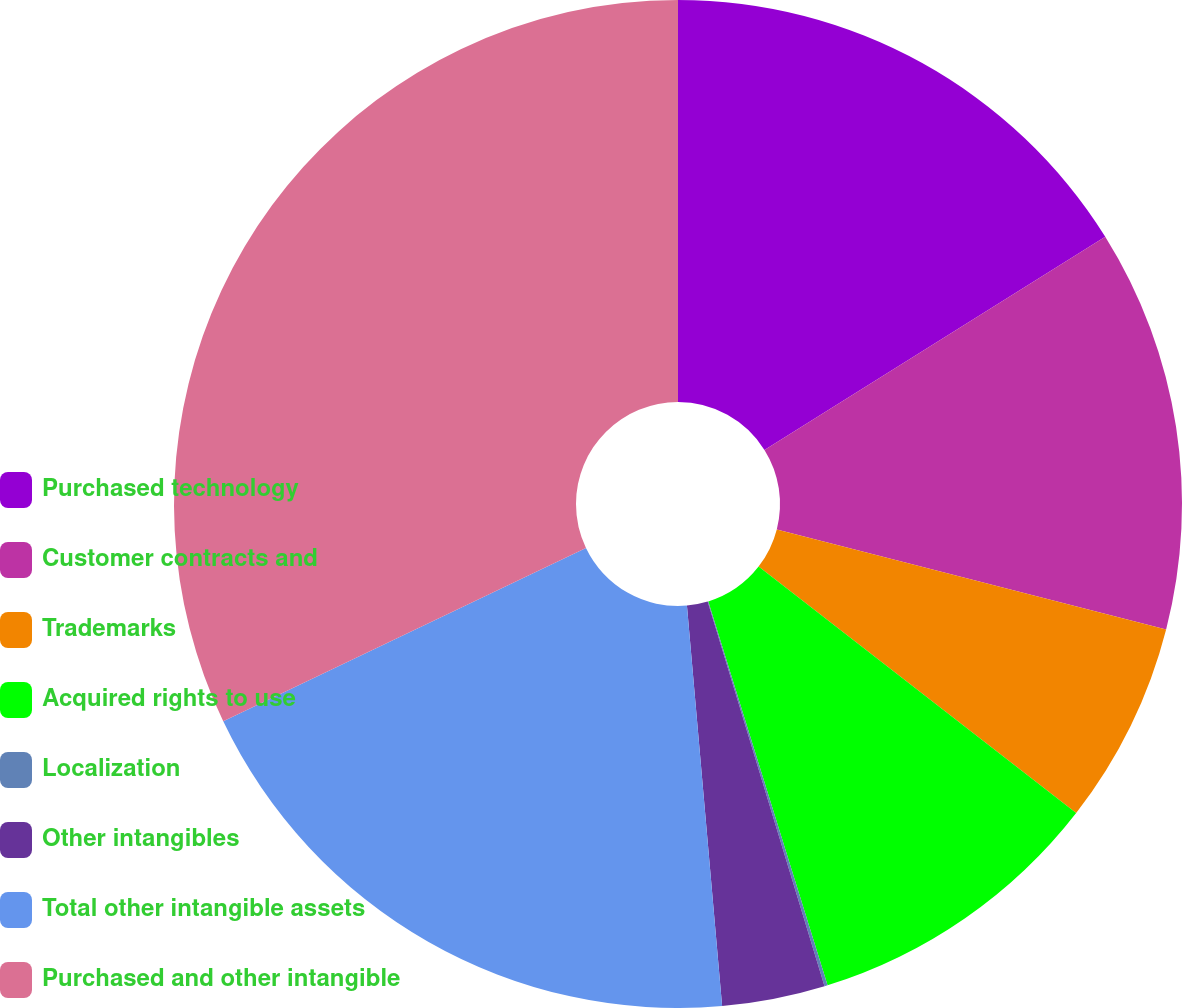<chart> <loc_0><loc_0><loc_500><loc_500><pie_chart><fcel>Purchased technology<fcel>Customer contracts and<fcel>Trademarks<fcel>Acquired rights to use<fcel>Localization<fcel>Other intangibles<fcel>Total other intangible assets<fcel>Purchased and other intangible<nl><fcel>16.1%<fcel>12.9%<fcel>6.5%<fcel>9.7%<fcel>0.1%<fcel>3.3%<fcel>19.3%<fcel>32.09%<nl></chart> 